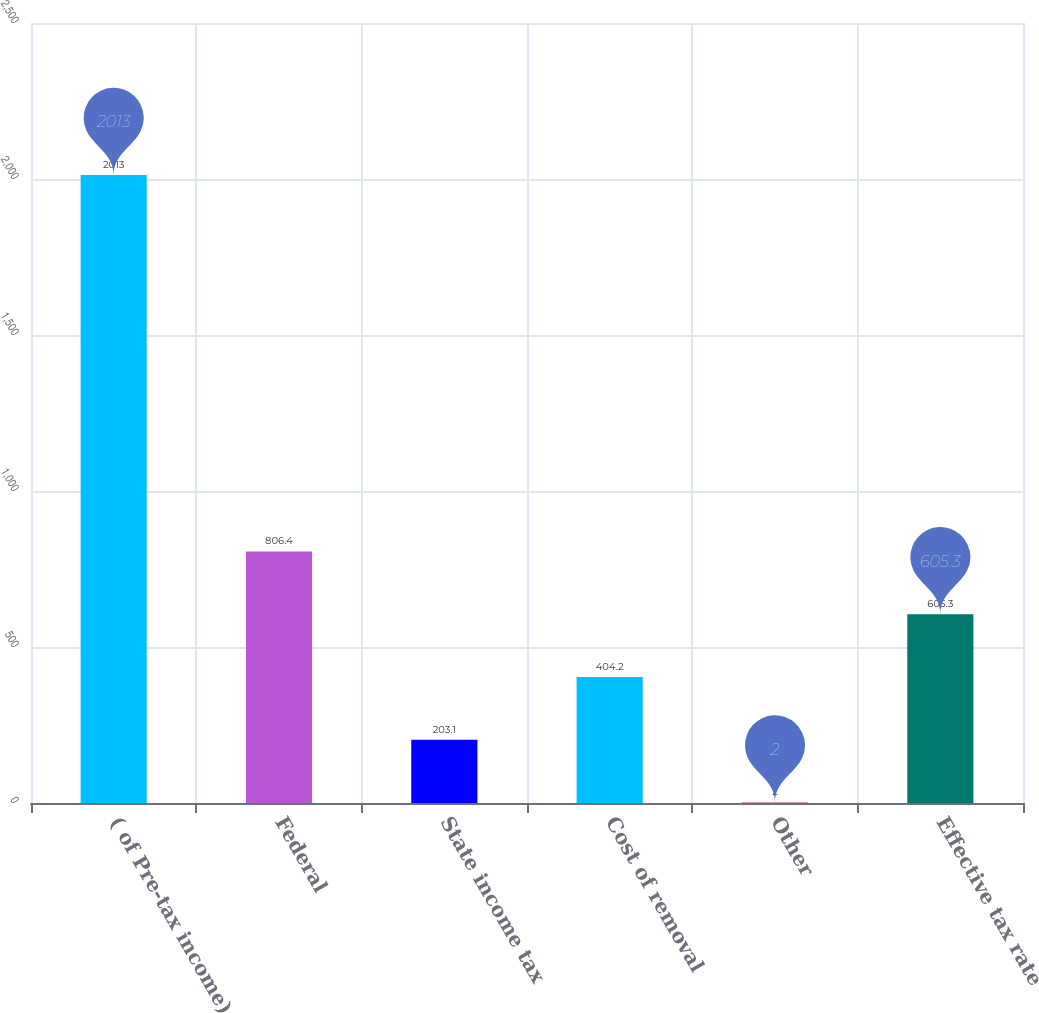Convert chart to OTSL. <chart><loc_0><loc_0><loc_500><loc_500><bar_chart><fcel>( of Pre-tax income)<fcel>Federal<fcel>State income tax<fcel>Cost of removal<fcel>Other<fcel>Effective tax rate<nl><fcel>2013<fcel>806.4<fcel>203.1<fcel>404.2<fcel>2<fcel>605.3<nl></chart> 